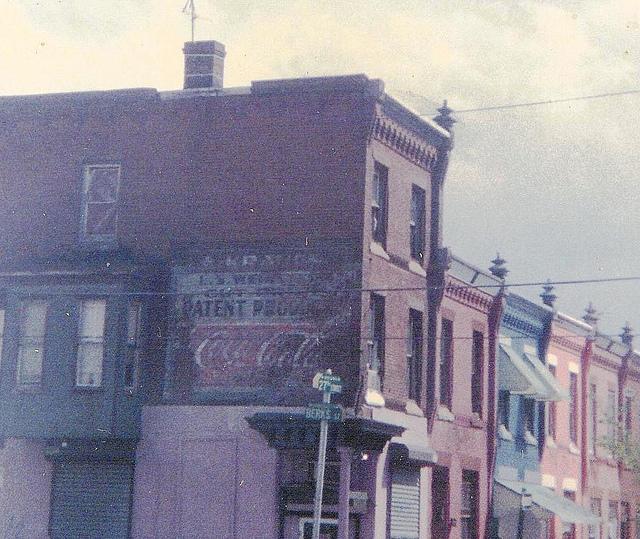Which is the brand name of soda?
Short answer required. Coca cola. What material is the building made of?
Concise answer only. Brick. How many buildings do you see?
Be succinct. 6. What is the business being shown?
Quick response, please. Coca cola. 